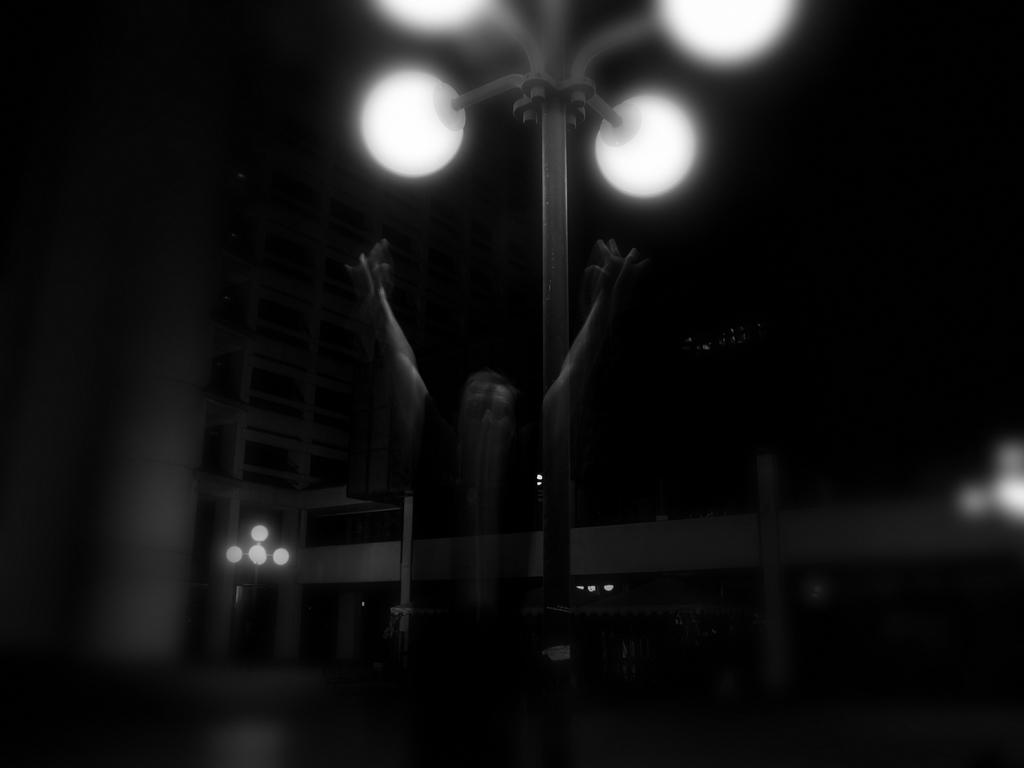What is the color scheme of the image? The image is black and white. What can be seen in the image that might represent a spiritual or intangible concept? There is a soul in the image, although interpretation may vary. What type of illumination is present in the image? There are lights in the image. What structures are present in the image that might provide support or guidance? There are poles in the image. What type of man-made structure is visible in the image? There is a building in the image. What type of plant is gripping the soul in the image? There is no plant present in the image, nor is there any indication of a grip on the soul. 